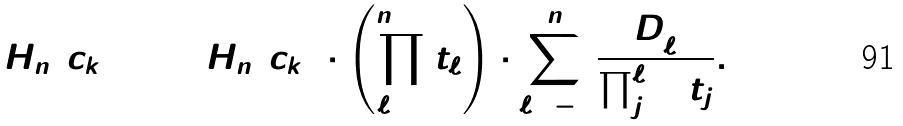Convert formula to latex. <formula><loc_0><loc_0><loc_500><loc_500>H _ { n } ( c _ { k + 2 } ) = H _ { n } ( c _ { k } ) \cdot \left ( \prod _ { \ell = 1 } ^ { n + 1 } t _ { \ell } \right ) \cdot \sum _ { \ell = - 1 } ^ { n } \frac { D _ { \ell } ^ { 2 } } { \prod _ { j = 1 } ^ { \ell + 1 } t _ { j } } .</formula> 